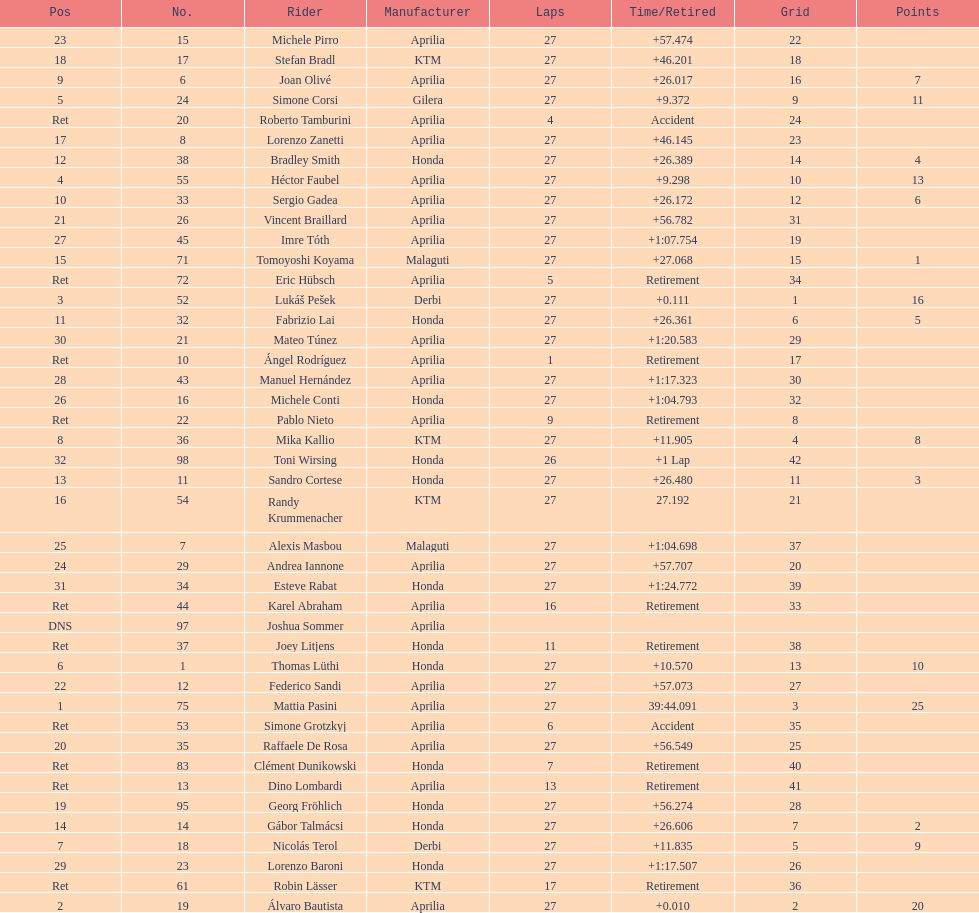Which rider came in first with 25 points? Mattia Pasini. Can you parse all the data within this table? {'header': ['Pos', 'No.', 'Rider', 'Manufacturer', 'Laps', 'Time/Retired', 'Grid', 'Points'], 'rows': [['23', '15', 'Michele Pirro', 'Aprilia', '27', '+57.474', '22', ''], ['18', '17', 'Stefan Bradl', 'KTM', '27', '+46.201', '18', ''], ['9', '6', 'Joan Olivé', 'Aprilia', '27', '+26.017', '16', '7'], ['5', '24', 'Simone Corsi', 'Gilera', '27', '+9.372', '9', '11'], ['Ret', '20', 'Roberto Tamburini', 'Aprilia', '4', 'Accident', '24', ''], ['17', '8', 'Lorenzo Zanetti', 'Aprilia', '27', '+46.145', '23', ''], ['12', '38', 'Bradley Smith', 'Honda', '27', '+26.389', '14', '4'], ['4', '55', 'Héctor Faubel', 'Aprilia', '27', '+9.298', '10', '13'], ['10', '33', 'Sergio Gadea', 'Aprilia', '27', '+26.172', '12', '6'], ['21', '26', 'Vincent Braillard', 'Aprilia', '27', '+56.782', '31', ''], ['27', '45', 'Imre Tóth', 'Aprilia', '27', '+1:07.754', '19', ''], ['15', '71', 'Tomoyoshi Koyama', 'Malaguti', '27', '+27.068', '15', '1'], ['Ret', '72', 'Eric Hübsch', 'Aprilia', '5', 'Retirement', '34', ''], ['3', '52', 'Lukáš Pešek', 'Derbi', '27', '+0.111', '1', '16'], ['11', '32', 'Fabrizio Lai', 'Honda', '27', '+26.361', '6', '5'], ['30', '21', 'Mateo Túnez', 'Aprilia', '27', '+1:20.583', '29', ''], ['Ret', '10', 'Ángel Rodríguez', 'Aprilia', '1', 'Retirement', '17', ''], ['28', '43', 'Manuel Hernández', 'Aprilia', '27', '+1:17.323', '30', ''], ['26', '16', 'Michele Conti', 'Honda', '27', '+1:04.793', '32', ''], ['Ret', '22', 'Pablo Nieto', 'Aprilia', '9', 'Retirement', '8', ''], ['8', '36', 'Mika Kallio', 'KTM', '27', '+11.905', '4', '8'], ['32', '98', 'Toni Wirsing', 'Honda', '26', '+1 Lap', '42', ''], ['13', '11', 'Sandro Cortese', 'Honda', '27', '+26.480', '11', '3'], ['16', '54', 'Randy Krummenacher', 'KTM', '27', '27.192', '21', ''], ['25', '7', 'Alexis Masbou', 'Malaguti', '27', '+1:04.698', '37', ''], ['24', '29', 'Andrea Iannone', 'Aprilia', '27', '+57.707', '20', ''], ['31', '34', 'Esteve Rabat', 'Honda', '27', '+1:24.772', '39', ''], ['Ret', '44', 'Karel Abraham', 'Aprilia', '16', 'Retirement', '33', ''], ['DNS', '97', 'Joshua Sommer', 'Aprilia', '', '', '', ''], ['Ret', '37', 'Joey Litjens', 'Honda', '11', 'Retirement', '38', ''], ['6', '1', 'Thomas Lüthi', 'Honda', '27', '+10.570', '13', '10'], ['22', '12', 'Federico Sandi', 'Aprilia', '27', '+57.073', '27', ''], ['1', '75', 'Mattia Pasini', 'Aprilia', '27', '39:44.091', '3', '25'], ['Ret', '53', 'Simone Grotzkyj', 'Aprilia', '6', 'Accident', '35', ''], ['20', '35', 'Raffaele De Rosa', 'Aprilia', '27', '+56.549', '25', ''], ['Ret', '83', 'Clément Dunikowski', 'Honda', '7', 'Retirement', '40', ''], ['Ret', '13', 'Dino Lombardi', 'Aprilia', '13', 'Retirement', '41', ''], ['19', '95', 'Georg Fröhlich', 'Honda', '27', '+56.274', '28', ''], ['14', '14', 'Gábor Talmácsi', 'Honda', '27', '+26.606', '7', '2'], ['7', '18', 'Nicolás Terol', 'Derbi', '27', '+11.835', '5', '9'], ['29', '23', 'Lorenzo Baroni', 'Honda', '27', '+1:17.507', '26', ''], ['Ret', '61', 'Robin Lässer', 'KTM', '17', 'Retirement', '36', ''], ['2', '19', 'Álvaro Bautista', 'Aprilia', '27', '+0.010', '2', '20']]} 